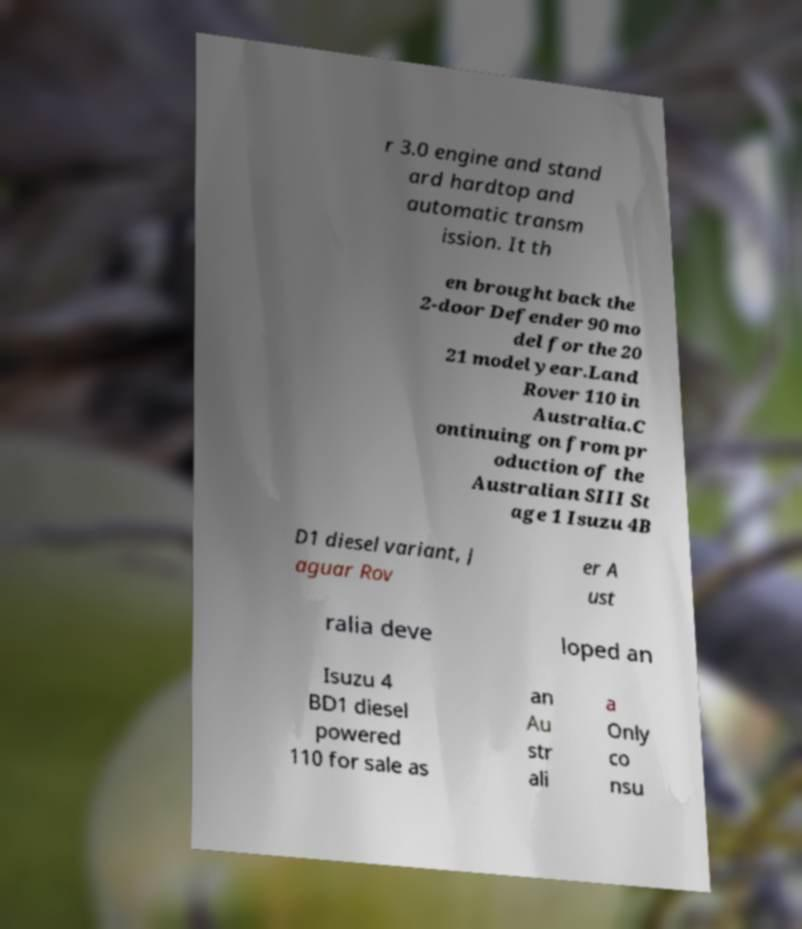Can you accurately transcribe the text from the provided image for me? r 3.0 engine and stand ard hardtop and automatic transm ission. It th en brought back the 2-door Defender 90 mo del for the 20 21 model year.Land Rover 110 in Australia.C ontinuing on from pr oduction of the Australian SIII St age 1 Isuzu 4B D1 diesel variant, J aguar Rov er A ust ralia deve loped an Isuzu 4 BD1 diesel powered 110 for sale as an Au str ali a Only co nsu 